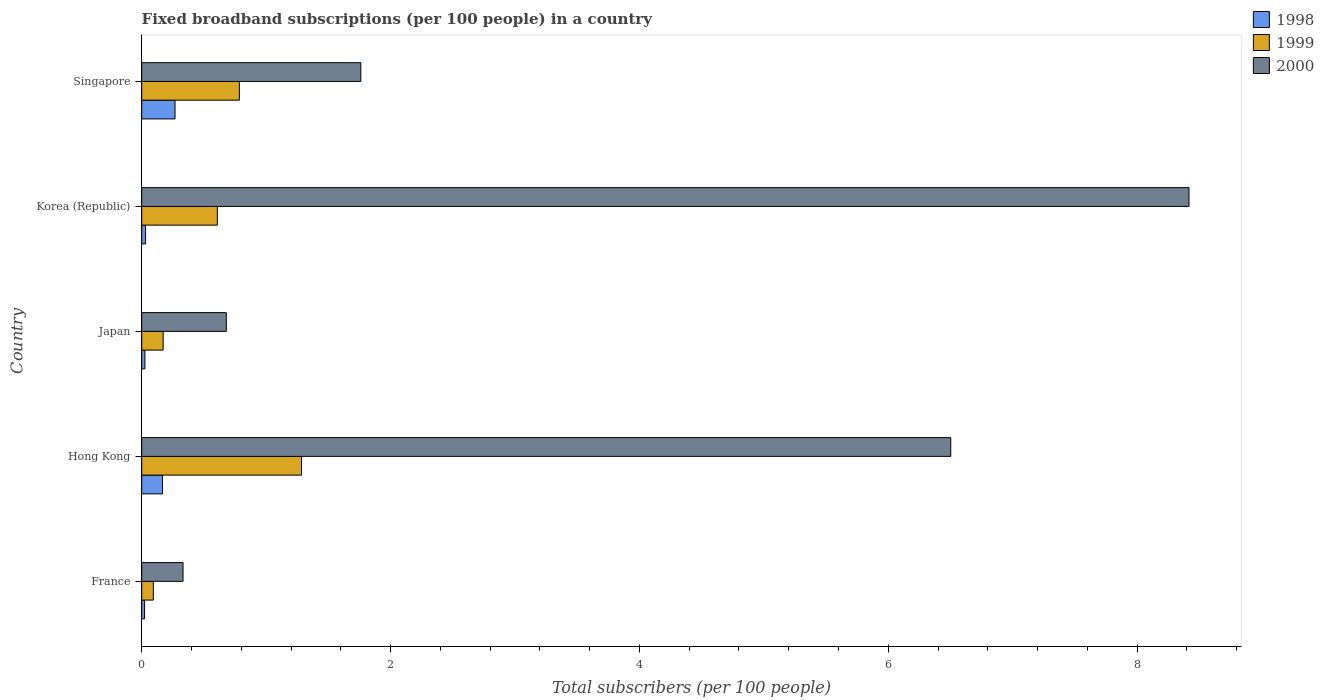How many groups of bars are there?
Provide a short and direct response. 5. Are the number of bars on each tick of the Y-axis equal?
Offer a terse response. Yes. How many bars are there on the 1st tick from the top?
Offer a terse response. 3. What is the label of the 4th group of bars from the top?
Your response must be concise. Hong Kong. In how many cases, is the number of bars for a given country not equal to the number of legend labels?
Provide a succinct answer. 0. What is the number of broadband subscriptions in 1998 in Hong Kong?
Your answer should be very brief. 0.17. Across all countries, what is the maximum number of broadband subscriptions in 1999?
Offer a terse response. 1.28. Across all countries, what is the minimum number of broadband subscriptions in 1998?
Keep it short and to the point. 0.02. In which country was the number of broadband subscriptions in 1998 maximum?
Your response must be concise. Singapore. What is the total number of broadband subscriptions in 1998 in the graph?
Provide a short and direct response. 0.51. What is the difference between the number of broadband subscriptions in 2000 in Hong Kong and that in Korea (Republic)?
Make the answer very short. -1.91. What is the difference between the number of broadband subscriptions in 2000 in Hong Kong and the number of broadband subscriptions in 1999 in Korea (Republic)?
Your response must be concise. 5.89. What is the average number of broadband subscriptions in 2000 per country?
Offer a terse response. 3.54. What is the difference between the number of broadband subscriptions in 2000 and number of broadband subscriptions in 1998 in Korea (Republic)?
Provide a short and direct response. 8.39. In how many countries, is the number of broadband subscriptions in 1999 greater than 2 ?
Your answer should be compact. 0. What is the ratio of the number of broadband subscriptions in 2000 in Japan to that in Singapore?
Your answer should be very brief. 0.39. Is the number of broadband subscriptions in 1998 in Hong Kong less than that in Japan?
Give a very brief answer. No. What is the difference between the highest and the second highest number of broadband subscriptions in 1999?
Provide a short and direct response. 0.5. What is the difference between the highest and the lowest number of broadband subscriptions in 1999?
Your answer should be very brief. 1.19. In how many countries, is the number of broadband subscriptions in 1999 greater than the average number of broadband subscriptions in 1999 taken over all countries?
Make the answer very short. 3. What does the 3rd bar from the top in Japan represents?
Make the answer very short. 1998. What does the 3rd bar from the bottom in Hong Kong represents?
Offer a terse response. 2000. Are all the bars in the graph horizontal?
Your response must be concise. Yes. How many countries are there in the graph?
Ensure brevity in your answer.  5. What is the difference between two consecutive major ticks on the X-axis?
Ensure brevity in your answer.  2. Are the values on the major ticks of X-axis written in scientific E-notation?
Provide a short and direct response. No. Does the graph contain grids?
Give a very brief answer. No. Where does the legend appear in the graph?
Your answer should be compact. Top right. How many legend labels are there?
Your answer should be compact. 3. What is the title of the graph?
Your answer should be compact. Fixed broadband subscriptions (per 100 people) in a country. What is the label or title of the X-axis?
Your response must be concise. Total subscribers (per 100 people). What is the label or title of the Y-axis?
Keep it short and to the point. Country. What is the Total subscribers (per 100 people) in 1998 in France?
Offer a terse response. 0.02. What is the Total subscribers (per 100 people) in 1999 in France?
Your response must be concise. 0.09. What is the Total subscribers (per 100 people) of 2000 in France?
Your answer should be compact. 0.33. What is the Total subscribers (per 100 people) in 1998 in Hong Kong?
Your answer should be very brief. 0.17. What is the Total subscribers (per 100 people) in 1999 in Hong Kong?
Provide a short and direct response. 1.28. What is the Total subscribers (per 100 people) in 2000 in Hong Kong?
Your answer should be compact. 6.5. What is the Total subscribers (per 100 people) in 1998 in Japan?
Provide a short and direct response. 0.03. What is the Total subscribers (per 100 people) in 1999 in Japan?
Offer a terse response. 0.17. What is the Total subscribers (per 100 people) in 2000 in Japan?
Ensure brevity in your answer.  0.68. What is the Total subscribers (per 100 people) of 1998 in Korea (Republic)?
Offer a very short reply. 0.03. What is the Total subscribers (per 100 people) in 1999 in Korea (Republic)?
Provide a succinct answer. 0.61. What is the Total subscribers (per 100 people) in 2000 in Korea (Republic)?
Your response must be concise. 8.42. What is the Total subscribers (per 100 people) of 1998 in Singapore?
Offer a very short reply. 0.27. What is the Total subscribers (per 100 people) of 1999 in Singapore?
Your answer should be very brief. 0.78. What is the Total subscribers (per 100 people) in 2000 in Singapore?
Offer a terse response. 1.76. Across all countries, what is the maximum Total subscribers (per 100 people) of 1998?
Provide a short and direct response. 0.27. Across all countries, what is the maximum Total subscribers (per 100 people) in 1999?
Your answer should be very brief. 1.28. Across all countries, what is the maximum Total subscribers (per 100 people) in 2000?
Keep it short and to the point. 8.42. Across all countries, what is the minimum Total subscribers (per 100 people) of 1998?
Keep it short and to the point. 0.02. Across all countries, what is the minimum Total subscribers (per 100 people) of 1999?
Make the answer very short. 0.09. Across all countries, what is the minimum Total subscribers (per 100 people) of 2000?
Offer a terse response. 0.33. What is the total Total subscribers (per 100 people) in 1998 in the graph?
Keep it short and to the point. 0.51. What is the total Total subscribers (per 100 people) of 1999 in the graph?
Keep it short and to the point. 2.94. What is the total Total subscribers (per 100 people) in 2000 in the graph?
Make the answer very short. 17.69. What is the difference between the Total subscribers (per 100 people) in 1998 in France and that in Hong Kong?
Provide a short and direct response. -0.14. What is the difference between the Total subscribers (per 100 people) in 1999 in France and that in Hong Kong?
Your response must be concise. -1.19. What is the difference between the Total subscribers (per 100 people) in 2000 in France and that in Hong Kong?
Make the answer very short. -6.17. What is the difference between the Total subscribers (per 100 people) in 1998 in France and that in Japan?
Your answer should be very brief. -0. What is the difference between the Total subscribers (per 100 people) in 1999 in France and that in Japan?
Make the answer very short. -0.08. What is the difference between the Total subscribers (per 100 people) in 2000 in France and that in Japan?
Give a very brief answer. -0.35. What is the difference between the Total subscribers (per 100 people) in 1998 in France and that in Korea (Republic)?
Your response must be concise. -0.01. What is the difference between the Total subscribers (per 100 people) in 1999 in France and that in Korea (Republic)?
Keep it short and to the point. -0.51. What is the difference between the Total subscribers (per 100 people) in 2000 in France and that in Korea (Republic)?
Your answer should be compact. -8.09. What is the difference between the Total subscribers (per 100 people) of 1998 in France and that in Singapore?
Give a very brief answer. -0.24. What is the difference between the Total subscribers (per 100 people) in 1999 in France and that in Singapore?
Give a very brief answer. -0.69. What is the difference between the Total subscribers (per 100 people) of 2000 in France and that in Singapore?
Make the answer very short. -1.43. What is the difference between the Total subscribers (per 100 people) in 1998 in Hong Kong and that in Japan?
Keep it short and to the point. 0.14. What is the difference between the Total subscribers (per 100 people) in 1999 in Hong Kong and that in Japan?
Offer a very short reply. 1.11. What is the difference between the Total subscribers (per 100 people) in 2000 in Hong Kong and that in Japan?
Provide a succinct answer. 5.82. What is the difference between the Total subscribers (per 100 people) in 1998 in Hong Kong and that in Korea (Republic)?
Offer a very short reply. 0.14. What is the difference between the Total subscribers (per 100 people) in 1999 in Hong Kong and that in Korea (Republic)?
Provide a short and direct response. 0.68. What is the difference between the Total subscribers (per 100 people) in 2000 in Hong Kong and that in Korea (Republic)?
Your answer should be very brief. -1.91. What is the difference between the Total subscribers (per 100 people) in 1998 in Hong Kong and that in Singapore?
Offer a terse response. -0.1. What is the difference between the Total subscribers (per 100 people) of 1999 in Hong Kong and that in Singapore?
Make the answer very short. 0.5. What is the difference between the Total subscribers (per 100 people) of 2000 in Hong Kong and that in Singapore?
Your answer should be very brief. 4.74. What is the difference between the Total subscribers (per 100 people) in 1998 in Japan and that in Korea (Republic)?
Provide a short and direct response. -0.01. What is the difference between the Total subscribers (per 100 people) in 1999 in Japan and that in Korea (Republic)?
Ensure brevity in your answer.  -0.44. What is the difference between the Total subscribers (per 100 people) in 2000 in Japan and that in Korea (Republic)?
Keep it short and to the point. -7.74. What is the difference between the Total subscribers (per 100 people) in 1998 in Japan and that in Singapore?
Offer a very short reply. -0.24. What is the difference between the Total subscribers (per 100 people) of 1999 in Japan and that in Singapore?
Keep it short and to the point. -0.61. What is the difference between the Total subscribers (per 100 people) of 2000 in Japan and that in Singapore?
Make the answer very short. -1.08. What is the difference between the Total subscribers (per 100 people) in 1998 in Korea (Republic) and that in Singapore?
Your answer should be compact. -0.24. What is the difference between the Total subscribers (per 100 people) in 1999 in Korea (Republic) and that in Singapore?
Your answer should be very brief. -0.18. What is the difference between the Total subscribers (per 100 people) in 2000 in Korea (Republic) and that in Singapore?
Keep it short and to the point. 6.66. What is the difference between the Total subscribers (per 100 people) in 1998 in France and the Total subscribers (per 100 people) in 1999 in Hong Kong?
Ensure brevity in your answer.  -1.26. What is the difference between the Total subscribers (per 100 people) in 1998 in France and the Total subscribers (per 100 people) in 2000 in Hong Kong?
Give a very brief answer. -6.48. What is the difference between the Total subscribers (per 100 people) in 1999 in France and the Total subscribers (per 100 people) in 2000 in Hong Kong?
Provide a succinct answer. -6.41. What is the difference between the Total subscribers (per 100 people) in 1998 in France and the Total subscribers (per 100 people) in 1999 in Japan?
Provide a short and direct response. -0.15. What is the difference between the Total subscribers (per 100 people) of 1998 in France and the Total subscribers (per 100 people) of 2000 in Japan?
Give a very brief answer. -0.66. What is the difference between the Total subscribers (per 100 people) of 1999 in France and the Total subscribers (per 100 people) of 2000 in Japan?
Your answer should be very brief. -0.59. What is the difference between the Total subscribers (per 100 people) of 1998 in France and the Total subscribers (per 100 people) of 1999 in Korea (Republic)?
Offer a terse response. -0.58. What is the difference between the Total subscribers (per 100 people) of 1998 in France and the Total subscribers (per 100 people) of 2000 in Korea (Republic)?
Offer a terse response. -8.39. What is the difference between the Total subscribers (per 100 people) in 1999 in France and the Total subscribers (per 100 people) in 2000 in Korea (Republic)?
Offer a terse response. -8.32. What is the difference between the Total subscribers (per 100 people) of 1998 in France and the Total subscribers (per 100 people) of 1999 in Singapore?
Your response must be concise. -0.76. What is the difference between the Total subscribers (per 100 people) in 1998 in France and the Total subscribers (per 100 people) in 2000 in Singapore?
Keep it short and to the point. -1.74. What is the difference between the Total subscribers (per 100 people) of 1999 in France and the Total subscribers (per 100 people) of 2000 in Singapore?
Provide a succinct answer. -1.67. What is the difference between the Total subscribers (per 100 people) in 1998 in Hong Kong and the Total subscribers (per 100 people) in 1999 in Japan?
Offer a terse response. -0.01. What is the difference between the Total subscribers (per 100 people) in 1998 in Hong Kong and the Total subscribers (per 100 people) in 2000 in Japan?
Make the answer very short. -0.51. What is the difference between the Total subscribers (per 100 people) in 1999 in Hong Kong and the Total subscribers (per 100 people) in 2000 in Japan?
Your answer should be compact. 0.6. What is the difference between the Total subscribers (per 100 people) of 1998 in Hong Kong and the Total subscribers (per 100 people) of 1999 in Korea (Republic)?
Give a very brief answer. -0.44. What is the difference between the Total subscribers (per 100 people) of 1998 in Hong Kong and the Total subscribers (per 100 people) of 2000 in Korea (Republic)?
Your response must be concise. -8.25. What is the difference between the Total subscribers (per 100 people) in 1999 in Hong Kong and the Total subscribers (per 100 people) in 2000 in Korea (Republic)?
Keep it short and to the point. -7.13. What is the difference between the Total subscribers (per 100 people) of 1998 in Hong Kong and the Total subscribers (per 100 people) of 1999 in Singapore?
Provide a succinct answer. -0.62. What is the difference between the Total subscribers (per 100 people) in 1998 in Hong Kong and the Total subscribers (per 100 people) in 2000 in Singapore?
Provide a succinct answer. -1.59. What is the difference between the Total subscribers (per 100 people) in 1999 in Hong Kong and the Total subscribers (per 100 people) in 2000 in Singapore?
Provide a succinct answer. -0.48. What is the difference between the Total subscribers (per 100 people) of 1998 in Japan and the Total subscribers (per 100 people) of 1999 in Korea (Republic)?
Provide a short and direct response. -0.58. What is the difference between the Total subscribers (per 100 people) in 1998 in Japan and the Total subscribers (per 100 people) in 2000 in Korea (Republic)?
Make the answer very short. -8.39. What is the difference between the Total subscribers (per 100 people) in 1999 in Japan and the Total subscribers (per 100 people) in 2000 in Korea (Republic)?
Give a very brief answer. -8.25. What is the difference between the Total subscribers (per 100 people) of 1998 in Japan and the Total subscribers (per 100 people) of 1999 in Singapore?
Offer a very short reply. -0.76. What is the difference between the Total subscribers (per 100 people) in 1998 in Japan and the Total subscribers (per 100 people) in 2000 in Singapore?
Your response must be concise. -1.74. What is the difference between the Total subscribers (per 100 people) of 1999 in Japan and the Total subscribers (per 100 people) of 2000 in Singapore?
Keep it short and to the point. -1.59. What is the difference between the Total subscribers (per 100 people) of 1998 in Korea (Republic) and the Total subscribers (per 100 people) of 1999 in Singapore?
Keep it short and to the point. -0.75. What is the difference between the Total subscribers (per 100 people) of 1998 in Korea (Republic) and the Total subscribers (per 100 people) of 2000 in Singapore?
Offer a very short reply. -1.73. What is the difference between the Total subscribers (per 100 people) of 1999 in Korea (Republic) and the Total subscribers (per 100 people) of 2000 in Singapore?
Your answer should be compact. -1.15. What is the average Total subscribers (per 100 people) of 1998 per country?
Ensure brevity in your answer.  0.1. What is the average Total subscribers (per 100 people) in 1999 per country?
Make the answer very short. 0.59. What is the average Total subscribers (per 100 people) in 2000 per country?
Your response must be concise. 3.54. What is the difference between the Total subscribers (per 100 people) in 1998 and Total subscribers (per 100 people) in 1999 in France?
Provide a succinct answer. -0.07. What is the difference between the Total subscribers (per 100 people) of 1998 and Total subscribers (per 100 people) of 2000 in France?
Your answer should be compact. -0.31. What is the difference between the Total subscribers (per 100 people) in 1999 and Total subscribers (per 100 people) in 2000 in France?
Offer a terse response. -0.24. What is the difference between the Total subscribers (per 100 people) in 1998 and Total subscribers (per 100 people) in 1999 in Hong Kong?
Your response must be concise. -1.12. What is the difference between the Total subscribers (per 100 people) of 1998 and Total subscribers (per 100 people) of 2000 in Hong Kong?
Keep it short and to the point. -6.34. What is the difference between the Total subscribers (per 100 people) in 1999 and Total subscribers (per 100 people) in 2000 in Hong Kong?
Provide a succinct answer. -5.22. What is the difference between the Total subscribers (per 100 people) in 1998 and Total subscribers (per 100 people) in 1999 in Japan?
Your answer should be compact. -0.15. What is the difference between the Total subscribers (per 100 people) in 1998 and Total subscribers (per 100 people) in 2000 in Japan?
Your answer should be compact. -0.65. What is the difference between the Total subscribers (per 100 people) in 1999 and Total subscribers (per 100 people) in 2000 in Japan?
Make the answer very short. -0.51. What is the difference between the Total subscribers (per 100 people) of 1998 and Total subscribers (per 100 people) of 1999 in Korea (Republic)?
Keep it short and to the point. -0.58. What is the difference between the Total subscribers (per 100 people) in 1998 and Total subscribers (per 100 people) in 2000 in Korea (Republic)?
Offer a terse response. -8.39. What is the difference between the Total subscribers (per 100 people) in 1999 and Total subscribers (per 100 people) in 2000 in Korea (Republic)?
Provide a short and direct response. -7.81. What is the difference between the Total subscribers (per 100 people) of 1998 and Total subscribers (per 100 people) of 1999 in Singapore?
Provide a succinct answer. -0.52. What is the difference between the Total subscribers (per 100 people) in 1998 and Total subscribers (per 100 people) in 2000 in Singapore?
Provide a short and direct response. -1.49. What is the difference between the Total subscribers (per 100 people) of 1999 and Total subscribers (per 100 people) of 2000 in Singapore?
Provide a short and direct response. -0.98. What is the ratio of the Total subscribers (per 100 people) in 1998 in France to that in Hong Kong?
Offer a very short reply. 0.14. What is the ratio of the Total subscribers (per 100 people) in 1999 in France to that in Hong Kong?
Your response must be concise. 0.07. What is the ratio of the Total subscribers (per 100 people) in 2000 in France to that in Hong Kong?
Ensure brevity in your answer.  0.05. What is the ratio of the Total subscribers (per 100 people) of 1998 in France to that in Japan?
Offer a very short reply. 0.9. What is the ratio of the Total subscribers (per 100 people) of 1999 in France to that in Japan?
Provide a short and direct response. 0.54. What is the ratio of the Total subscribers (per 100 people) in 2000 in France to that in Japan?
Ensure brevity in your answer.  0.49. What is the ratio of the Total subscribers (per 100 people) in 1998 in France to that in Korea (Republic)?
Your answer should be very brief. 0.75. What is the ratio of the Total subscribers (per 100 people) in 1999 in France to that in Korea (Republic)?
Your answer should be very brief. 0.15. What is the ratio of the Total subscribers (per 100 people) in 2000 in France to that in Korea (Republic)?
Offer a very short reply. 0.04. What is the ratio of the Total subscribers (per 100 people) in 1998 in France to that in Singapore?
Your answer should be very brief. 0.09. What is the ratio of the Total subscribers (per 100 people) of 1999 in France to that in Singapore?
Provide a succinct answer. 0.12. What is the ratio of the Total subscribers (per 100 people) of 2000 in France to that in Singapore?
Your answer should be very brief. 0.19. What is the ratio of the Total subscribers (per 100 people) of 1998 in Hong Kong to that in Japan?
Provide a succinct answer. 6.53. What is the ratio of the Total subscribers (per 100 people) in 1999 in Hong Kong to that in Japan?
Your answer should be compact. 7.46. What is the ratio of the Total subscribers (per 100 people) in 2000 in Hong Kong to that in Japan?
Provide a short and direct response. 9.56. What is the ratio of the Total subscribers (per 100 people) of 1998 in Hong Kong to that in Korea (Republic)?
Make the answer very short. 5.42. What is the ratio of the Total subscribers (per 100 people) in 1999 in Hong Kong to that in Korea (Republic)?
Offer a very short reply. 2.11. What is the ratio of the Total subscribers (per 100 people) in 2000 in Hong Kong to that in Korea (Republic)?
Give a very brief answer. 0.77. What is the ratio of the Total subscribers (per 100 people) in 1998 in Hong Kong to that in Singapore?
Your answer should be compact. 0.62. What is the ratio of the Total subscribers (per 100 people) in 1999 in Hong Kong to that in Singapore?
Provide a short and direct response. 1.64. What is the ratio of the Total subscribers (per 100 people) of 2000 in Hong Kong to that in Singapore?
Your response must be concise. 3.69. What is the ratio of the Total subscribers (per 100 people) in 1998 in Japan to that in Korea (Republic)?
Offer a very short reply. 0.83. What is the ratio of the Total subscribers (per 100 people) of 1999 in Japan to that in Korea (Republic)?
Ensure brevity in your answer.  0.28. What is the ratio of the Total subscribers (per 100 people) in 2000 in Japan to that in Korea (Republic)?
Your answer should be very brief. 0.08. What is the ratio of the Total subscribers (per 100 people) in 1998 in Japan to that in Singapore?
Give a very brief answer. 0.1. What is the ratio of the Total subscribers (per 100 people) in 1999 in Japan to that in Singapore?
Your answer should be compact. 0.22. What is the ratio of the Total subscribers (per 100 people) of 2000 in Japan to that in Singapore?
Provide a succinct answer. 0.39. What is the ratio of the Total subscribers (per 100 people) in 1998 in Korea (Republic) to that in Singapore?
Give a very brief answer. 0.12. What is the ratio of the Total subscribers (per 100 people) in 1999 in Korea (Republic) to that in Singapore?
Your answer should be compact. 0.77. What is the ratio of the Total subscribers (per 100 people) of 2000 in Korea (Republic) to that in Singapore?
Offer a terse response. 4.78. What is the difference between the highest and the second highest Total subscribers (per 100 people) in 1998?
Offer a terse response. 0.1. What is the difference between the highest and the second highest Total subscribers (per 100 people) in 1999?
Provide a succinct answer. 0.5. What is the difference between the highest and the second highest Total subscribers (per 100 people) of 2000?
Give a very brief answer. 1.91. What is the difference between the highest and the lowest Total subscribers (per 100 people) of 1998?
Provide a short and direct response. 0.24. What is the difference between the highest and the lowest Total subscribers (per 100 people) in 1999?
Offer a very short reply. 1.19. What is the difference between the highest and the lowest Total subscribers (per 100 people) of 2000?
Provide a succinct answer. 8.09. 